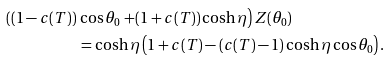Convert formula to latex. <formula><loc_0><loc_0><loc_500><loc_500>\left ( ( 1 - c ( T ) ) \right . & \cos \theta _ { 0 } \left . + ( 1 + c ( T ) ) \cosh \eta \right ) Z ( \theta _ { 0 } ) \\ & = \cosh \eta \left ( 1 + c ( T ) - ( c ( T ) - 1 ) \cosh \eta \cos \theta _ { 0 } \right ) .</formula> 